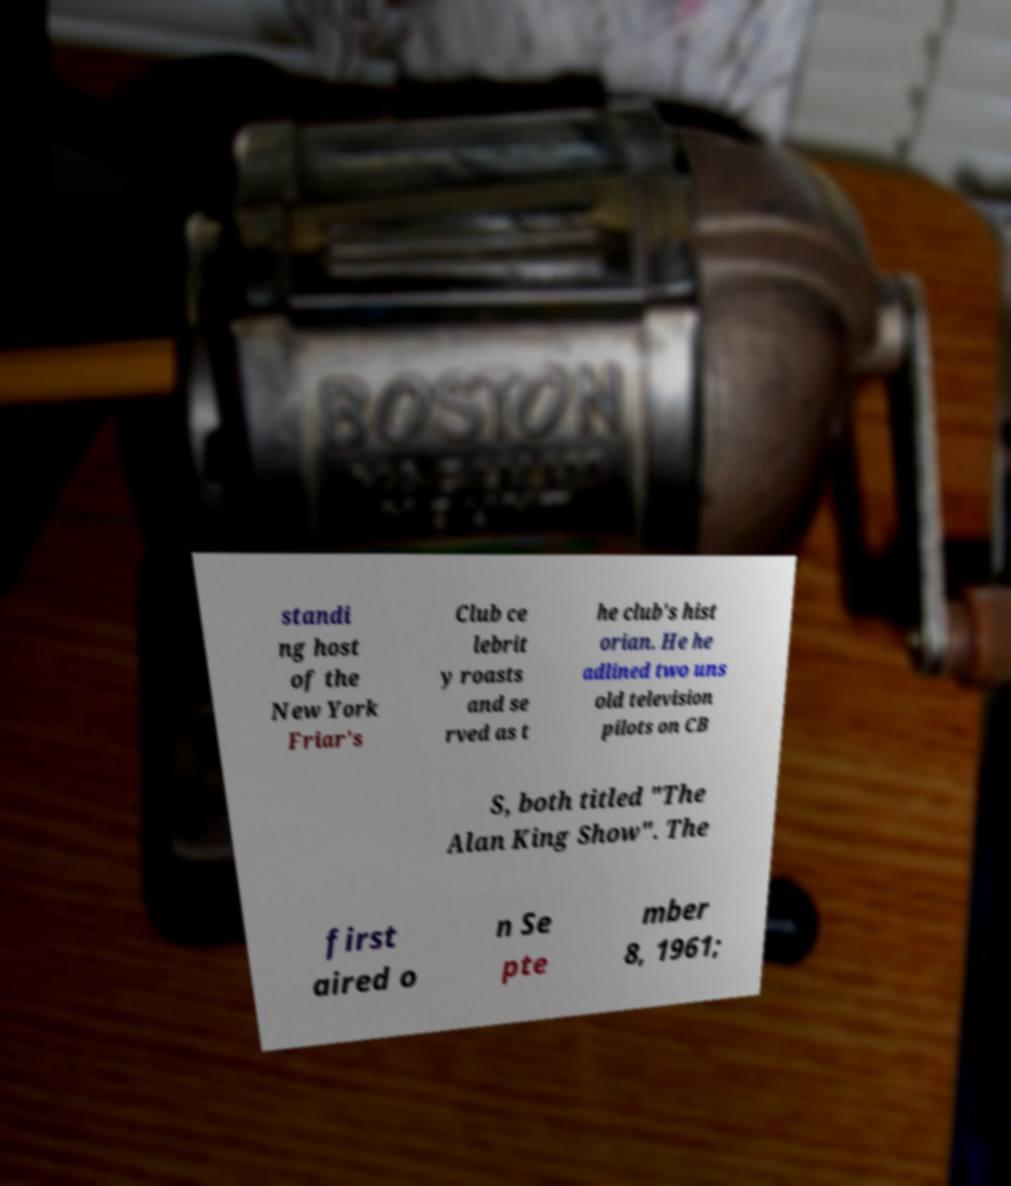Could you assist in decoding the text presented in this image and type it out clearly? standi ng host of the New York Friar's Club ce lebrit y roasts and se rved as t he club's hist orian. He he adlined two uns old television pilots on CB S, both titled "The Alan King Show". The first aired o n Se pte mber 8, 1961; 